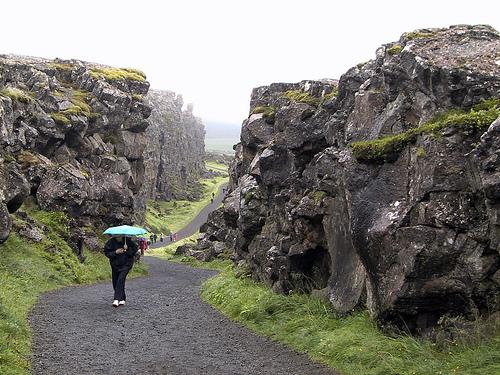Is this picture taken on the outside?
Give a very brief answer. Yes. What does the path lead too?
Concise answer only. Water. Where is the umbrella?
Short answer required. Over person. 